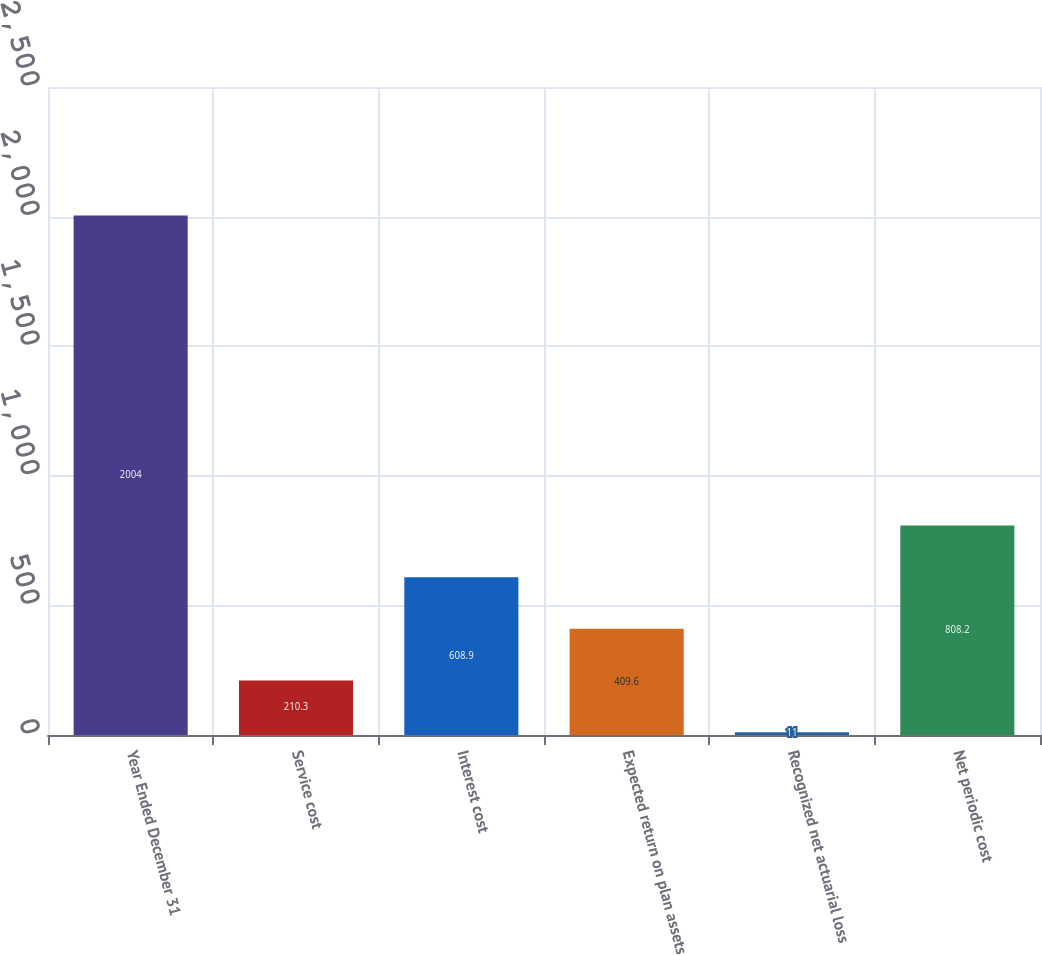Convert chart to OTSL. <chart><loc_0><loc_0><loc_500><loc_500><bar_chart><fcel>Year Ended December 31<fcel>Service cost<fcel>Interest cost<fcel>Expected return on plan assets<fcel>Recognized net actuarial loss<fcel>Net periodic cost<nl><fcel>2004<fcel>210.3<fcel>608.9<fcel>409.6<fcel>11<fcel>808.2<nl></chart> 